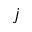<formula> <loc_0><loc_0><loc_500><loc_500>j</formula> 